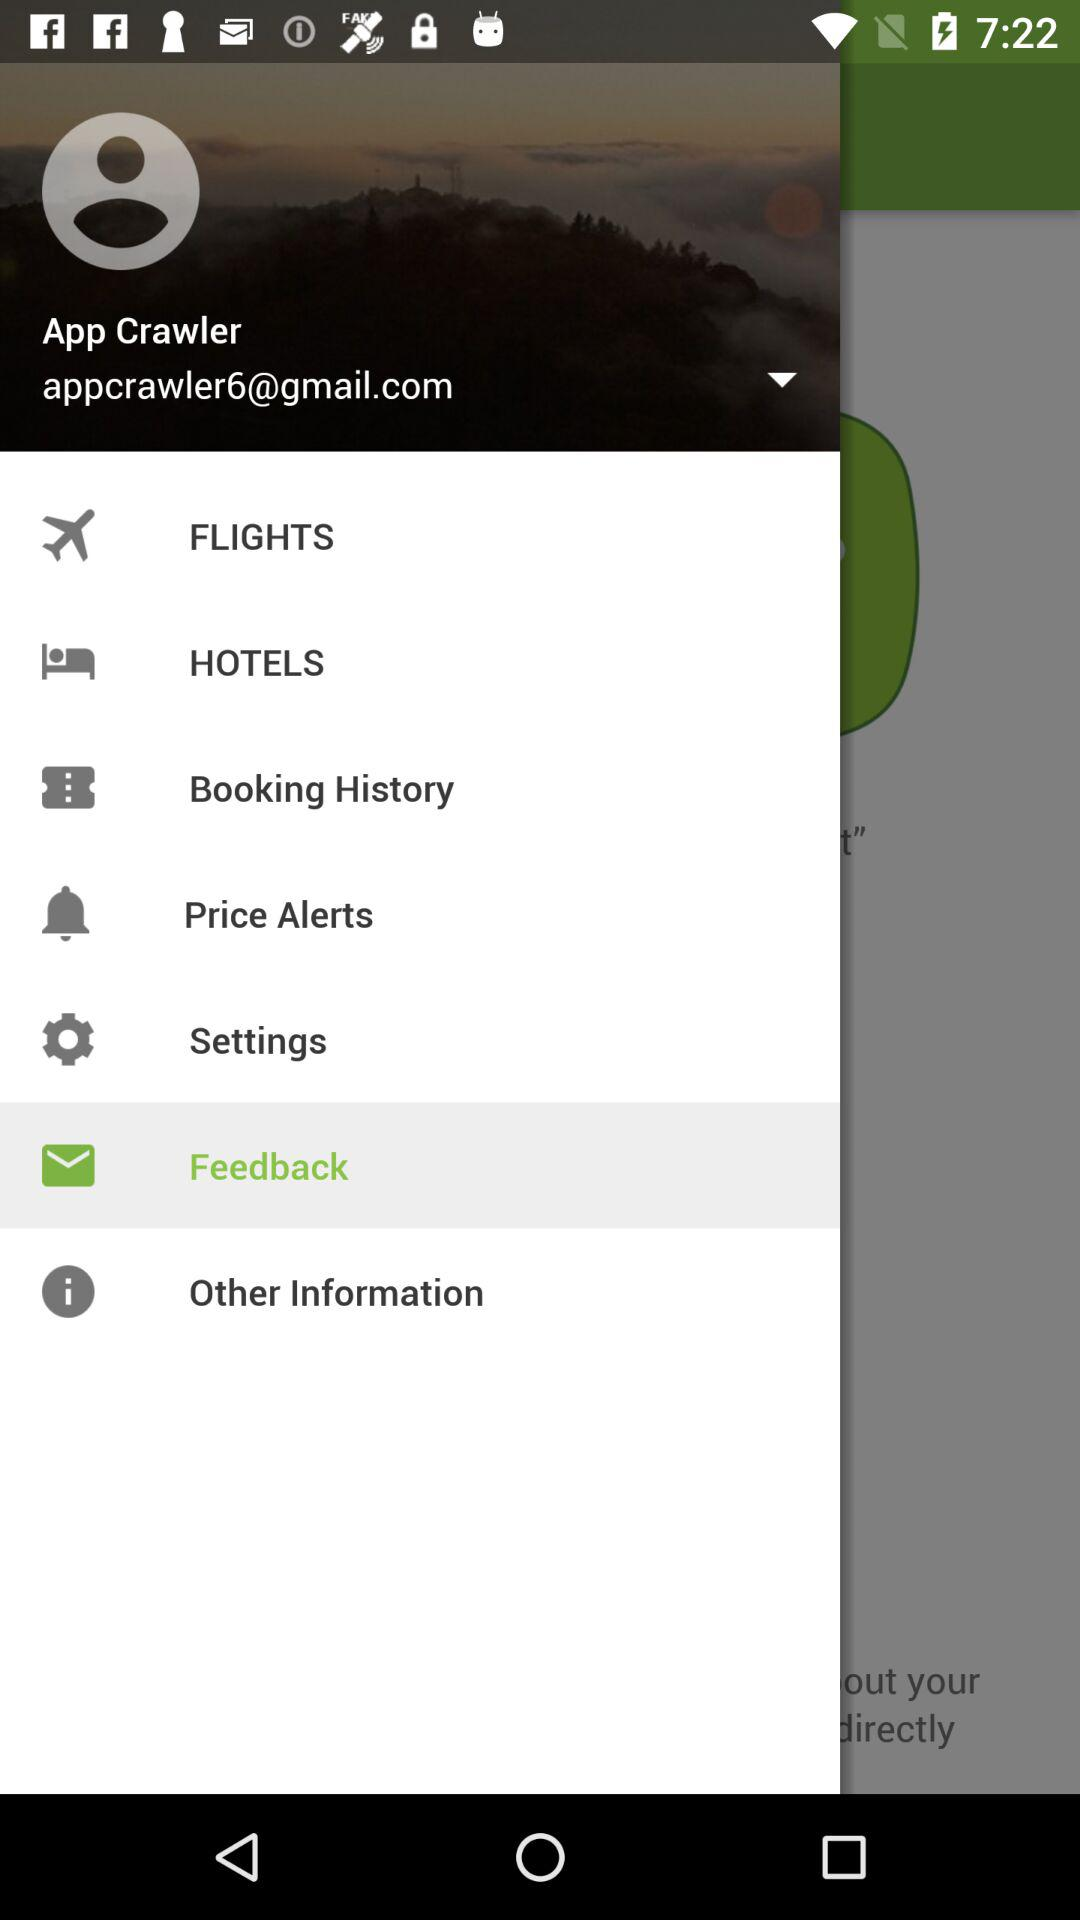What is the name of the user? The name of the user is App Crawler. 